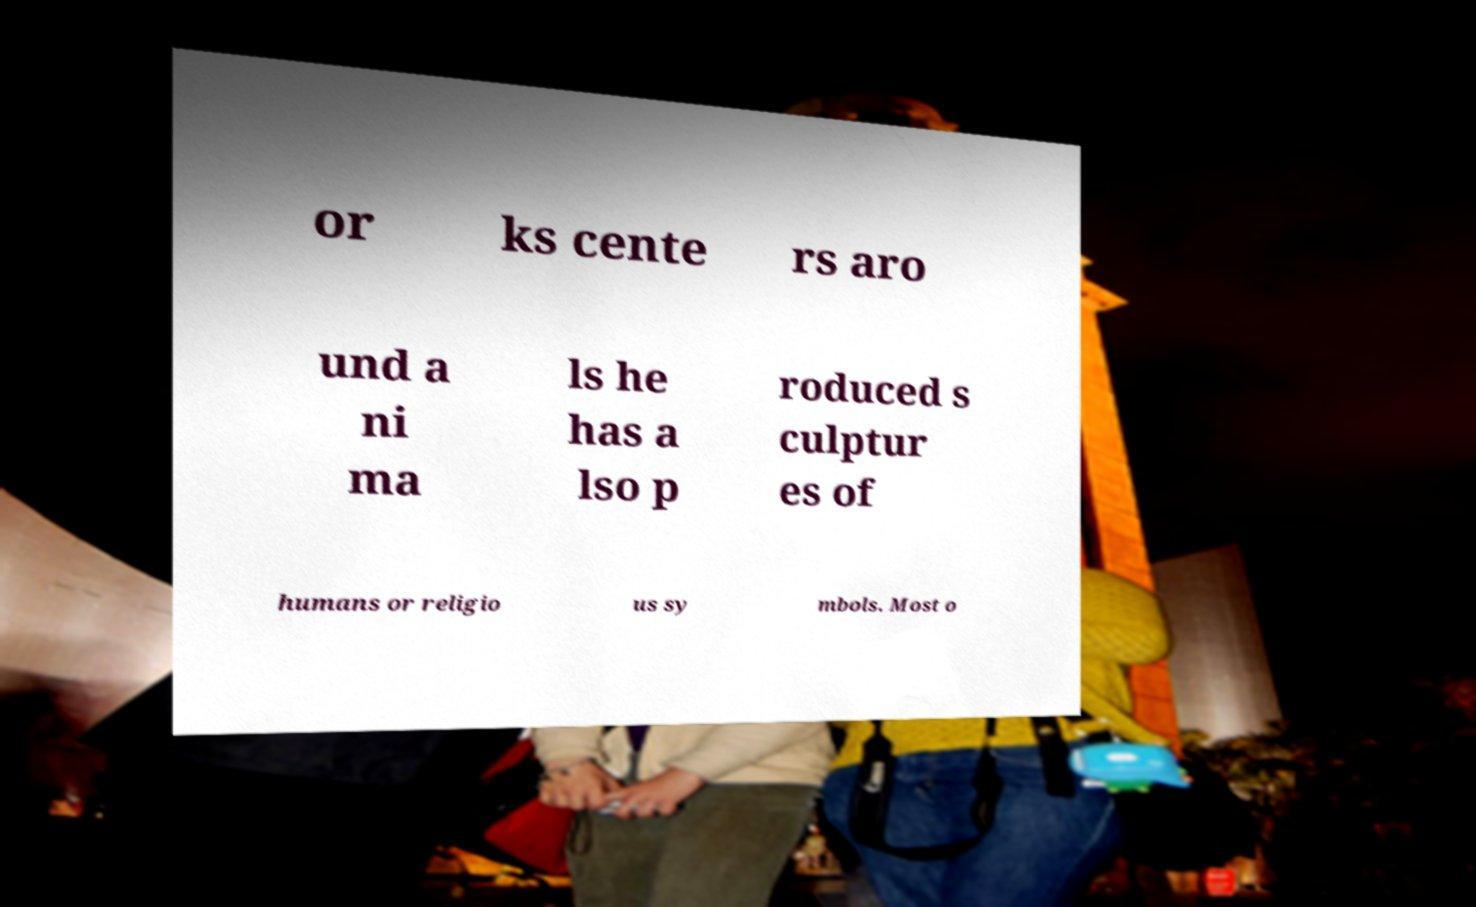What messages or text are displayed in this image? I need them in a readable, typed format. or ks cente rs aro und a ni ma ls he has a lso p roduced s culptur es of humans or religio us sy mbols. Most o 